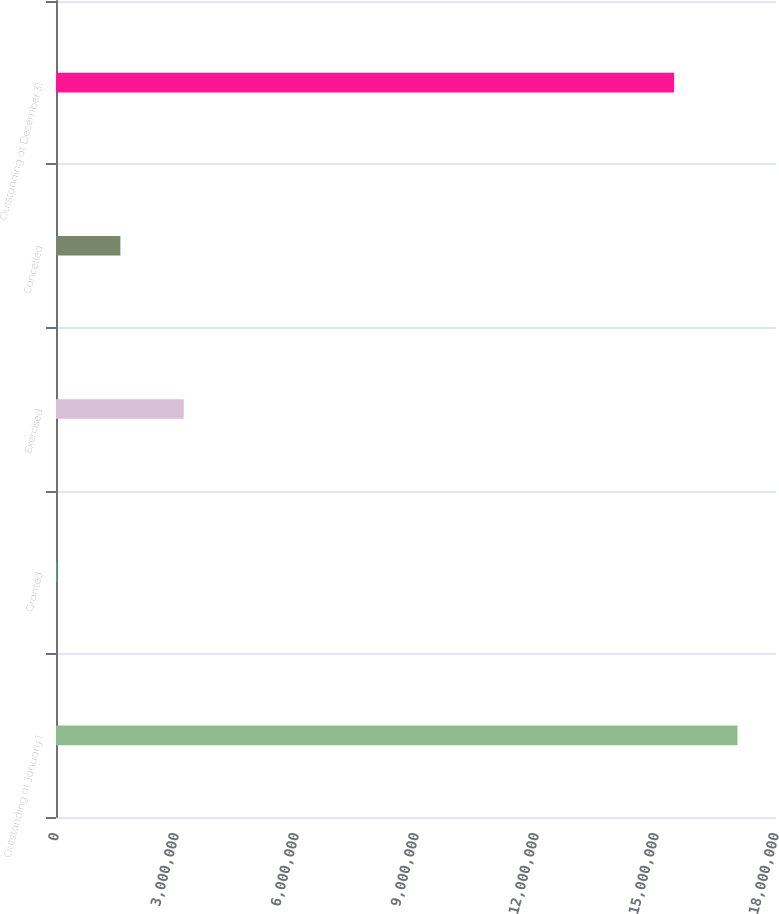Convert chart. <chart><loc_0><loc_0><loc_500><loc_500><bar_chart><fcel>Outstanding at January 1<fcel>Granted<fcel>Exercised<fcel>Cancelled<fcel>Outstanding at December 31<nl><fcel>1.70366e+07<fcel>26000<fcel>3.19305e+06<fcel>1.60953e+06<fcel>1.54531e+07<nl></chart> 